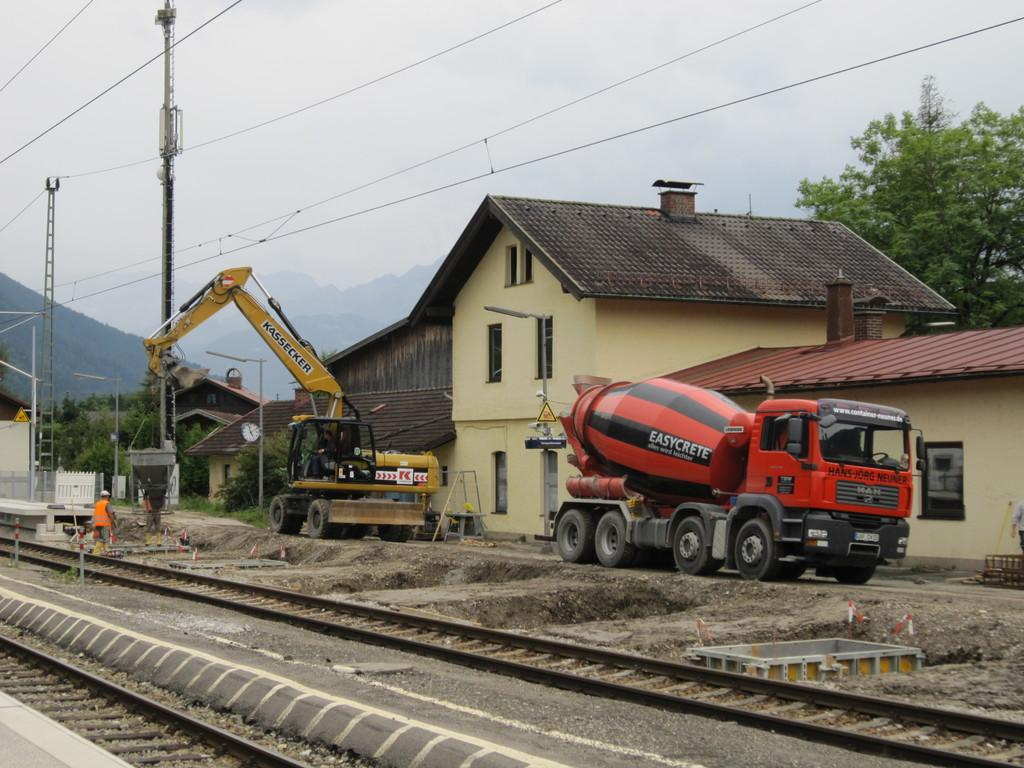<image>
Share a concise interpretation of the image provided. Red truck with the word "EasyCrete" near the back. 